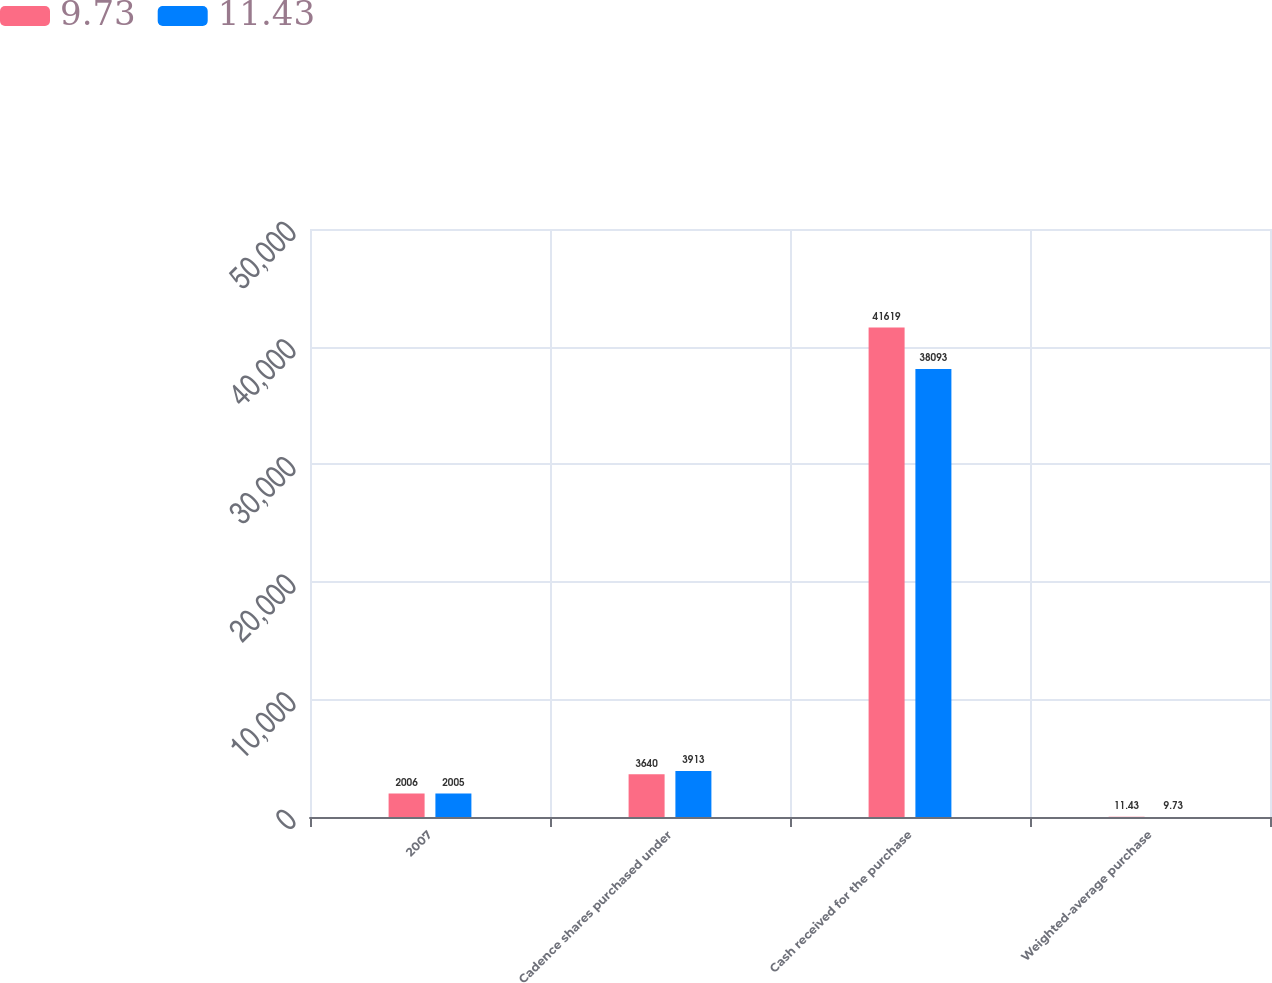Convert chart. <chart><loc_0><loc_0><loc_500><loc_500><stacked_bar_chart><ecel><fcel>2007<fcel>Cadence shares purchased under<fcel>Cash received for the purchase<fcel>Weighted-average purchase<nl><fcel>9.73<fcel>2006<fcel>3640<fcel>41619<fcel>11.43<nl><fcel>11.43<fcel>2005<fcel>3913<fcel>38093<fcel>9.73<nl></chart> 